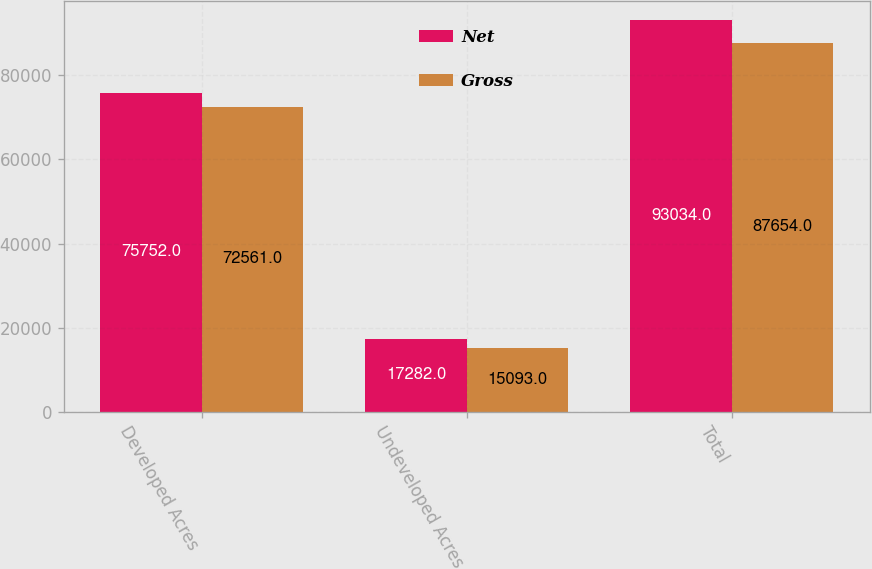<chart> <loc_0><loc_0><loc_500><loc_500><stacked_bar_chart><ecel><fcel>Developed Acres<fcel>Undeveloped Acres<fcel>Total<nl><fcel>Net<fcel>75752<fcel>17282<fcel>93034<nl><fcel>Gross<fcel>72561<fcel>15093<fcel>87654<nl></chart> 